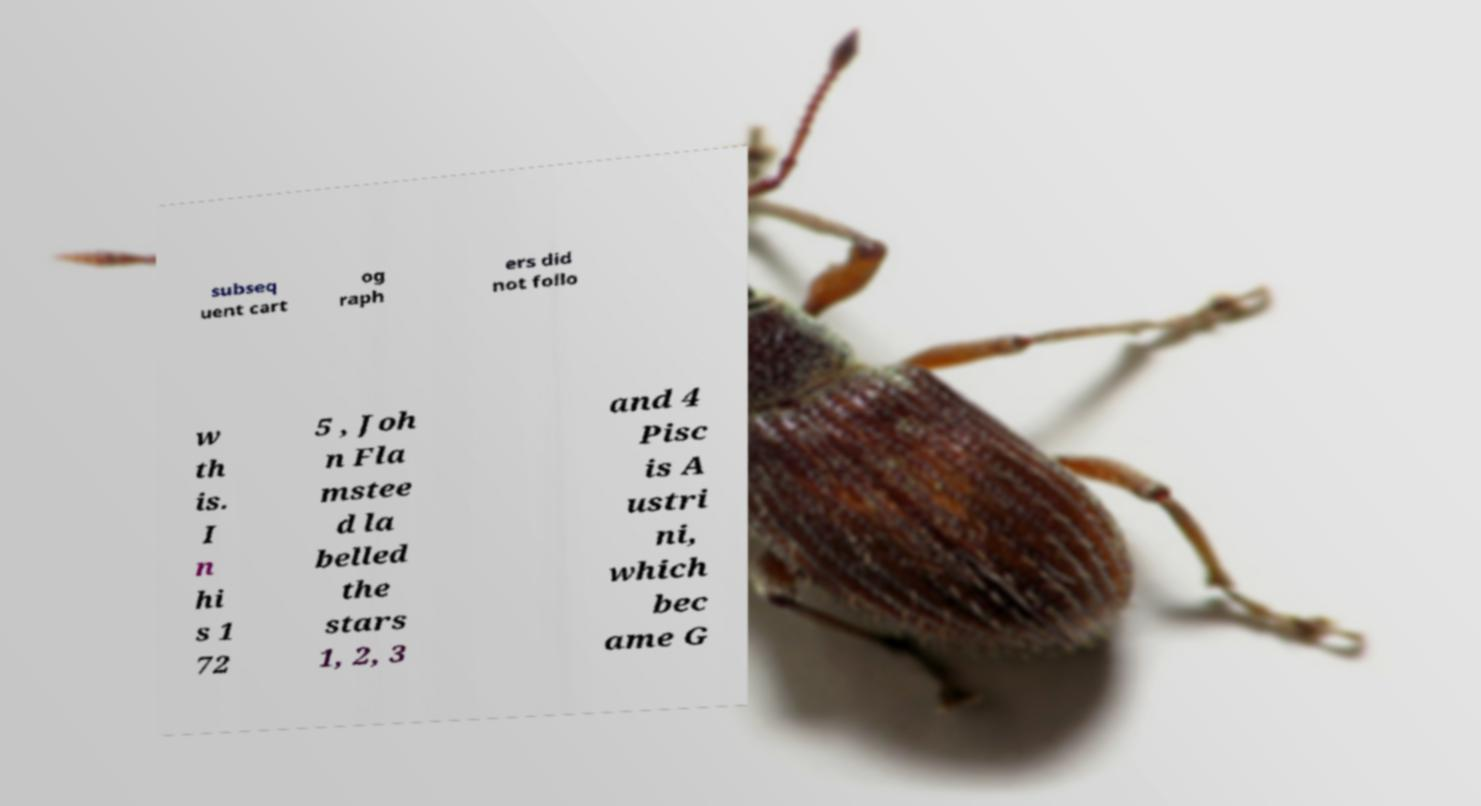Can you read and provide the text displayed in the image?This photo seems to have some interesting text. Can you extract and type it out for me? subseq uent cart og raph ers did not follo w th is. I n hi s 1 72 5 , Joh n Fla mstee d la belled the stars 1, 2, 3 and 4 Pisc is A ustri ni, which bec ame G 